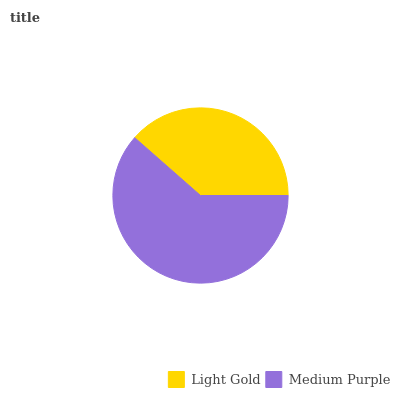Is Light Gold the minimum?
Answer yes or no. Yes. Is Medium Purple the maximum?
Answer yes or no. Yes. Is Medium Purple the minimum?
Answer yes or no. No. Is Medium Purple greater than Light Gold?
Answer yes or no. Yes. Is Light Gold less than Medium Purple?
Answer yes or no. Yes. Is Light Gold greater than Medium Purple?
Answer yes or no. No. Is Medium Purple less than Light Gold?
Answer yes or no. No. Is Medium Purple the high median?
Answer yes or no. Yes. Is Light Gold the low median?
Answer yes or no. Yes. Is Light Gold the high median?
Answer yes or no. No. Is Medium Purple the low median?
Answer yes or no. No. 